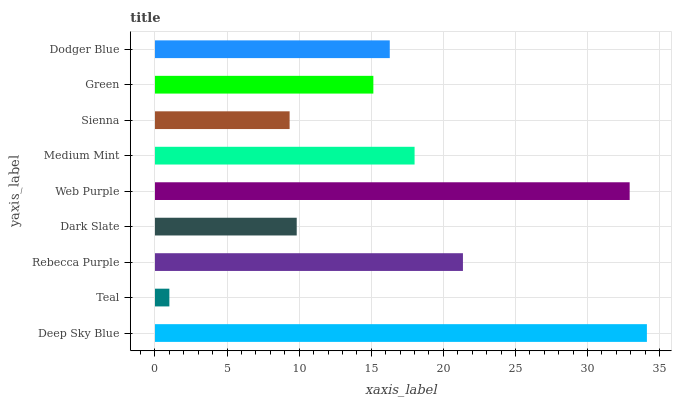Is Teal the minimum?
Answer yes or no. Yes. Is Deep Sky Blue the maximum?
Answer yes or no. Yes. Is Rebecca Purple the minimum?
Answer yes or no. No. Is Rebecca Purple the maximum?
Answer yes or no. No. Is Rebecca Purple greater than Teal?
Answer yes or no. Yes. Is Teal less than Rebecca Purple?
Answer yes or no. Yes. Is Teal greater than Rebecca Purple?
Answer yes or no. No. Is Rebecca Purple less than Teal?
Answer yes or no. No. Is Dodger Blue the high median?
Answer yes or no. Yes. Is Dodger Blue the low median?
Answer yes or no. Yes. Is Green the high median?
Answer yes or no. No. Is Teal the low median?
Answer yes or no. No. 